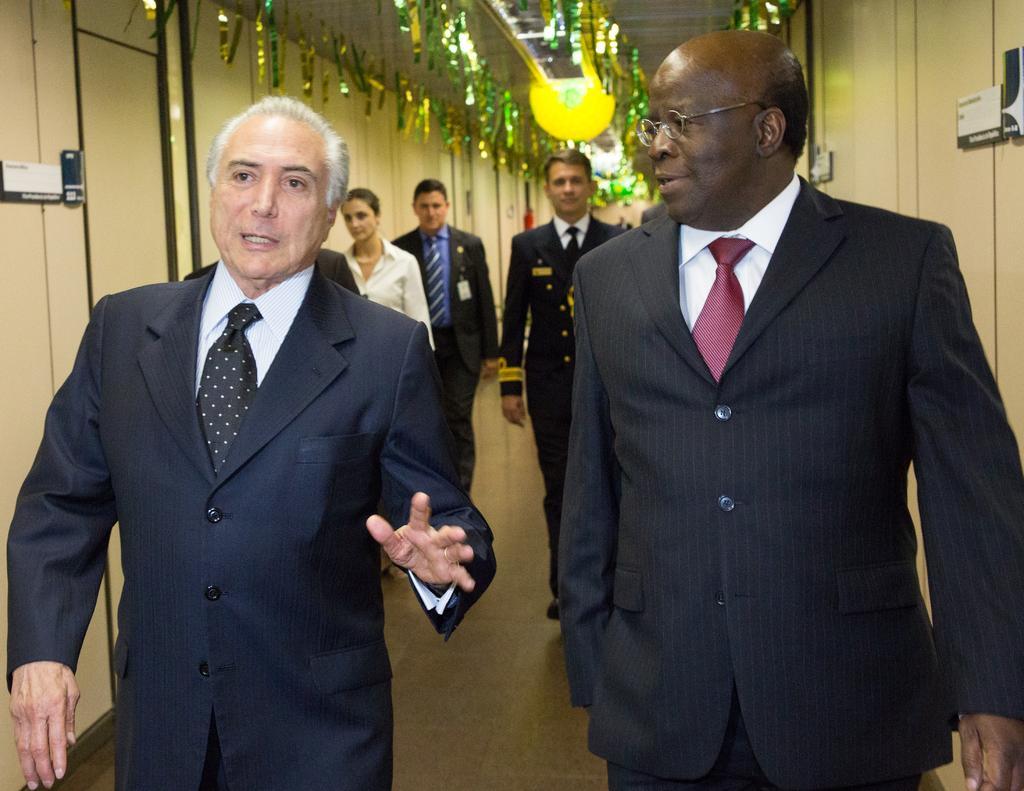Describe this image in one or two sentences. In this image on the right there is a man, he wears a suit, shirt, trouser, he is walking. On the left there is a man, he wears a suit, shirt, trouser, he is walking. In the middle there is a man, he wears a suit, shirt, trouser, he is walking and there are three people, they are walking. In the background there are lights, decorations, wall. 